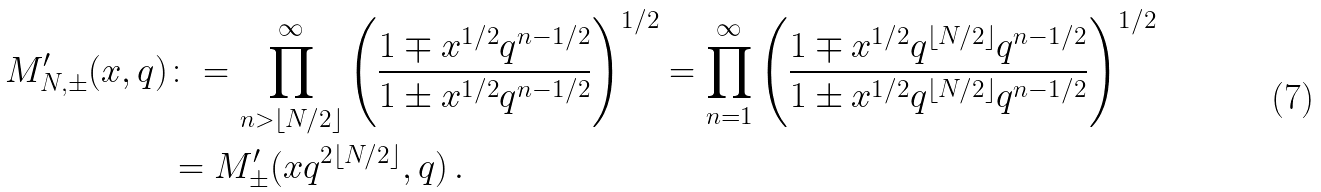Convert formula to latex. <formula><loc_0><loc_0><loc_500><loc_500>M ^ { \prime } _ { N , \pm } ( x , q ) & \colon = \prod _ { n > \lfloor N / 2 \rfloor } ^ { \infty } \left ( \frac { 1 \mp x ^ { 1 / 2 } q ^ { n - 1 / 2 } } { 1 \pm x ^ { 1 / 2 } q ^ { n - 1 / 2 } } \right ) ^ { 1 / 2 } = \prod _ { n = 1 } ^ { \infty } \left ( \frac { 1 \mp x ^ { 1 / 2 } q ^ { \lfloor N / 2 \rfloor } q ^ { n - 1 / 2 } } { 1 \pm x ^ { 1 / 2 } q ^ { \lfloor N / 2 \rfloor } q ^ { n - 1 / 2 } } \right ) ^ { 1 / 2 } \\ & = M ^ { \prime } _ { \pm } ( x q ^ { 2 \lfloor N / 2 \rfloor } , q ) \, .</formula> 